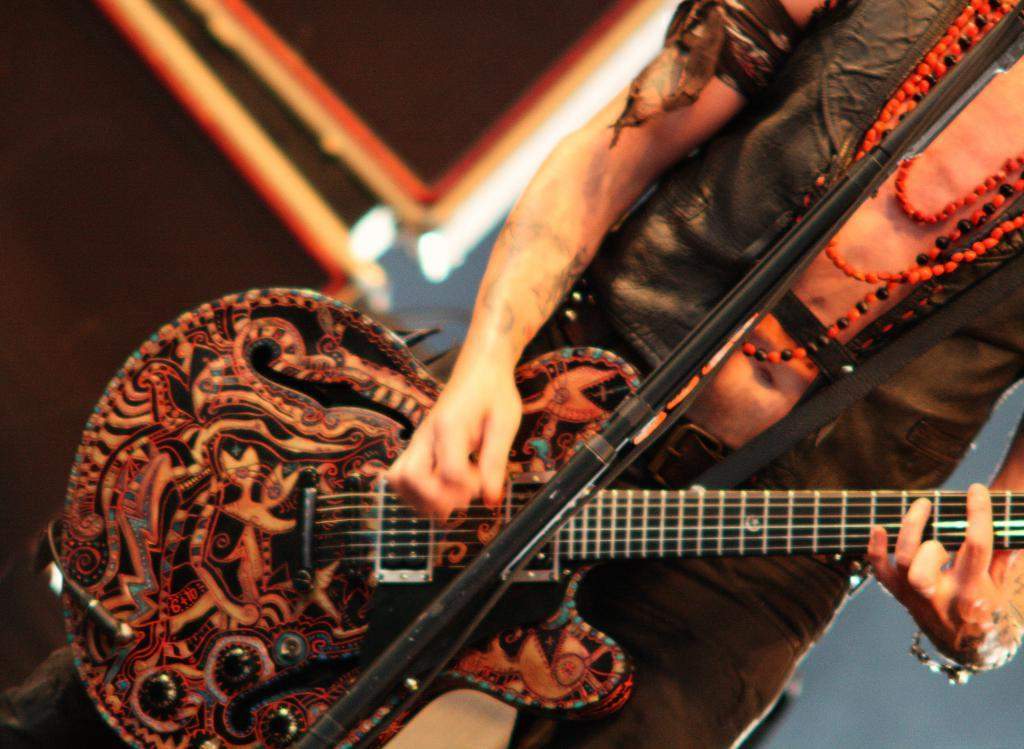What is the person in the image doing? The person is playing a guitar. What is in front of the person? There is a mic stand in front of the person. What is beside the person? There are speakers beside the person. What is the color of the background in the image? The background of the image is white. How many sheep can be seen participating in the activity in the image? There are no sheep present in the image, and the activity is playing the guitar. What type of band is performing in the image? There is no band present in the image; it features a single person playing the guitar. 